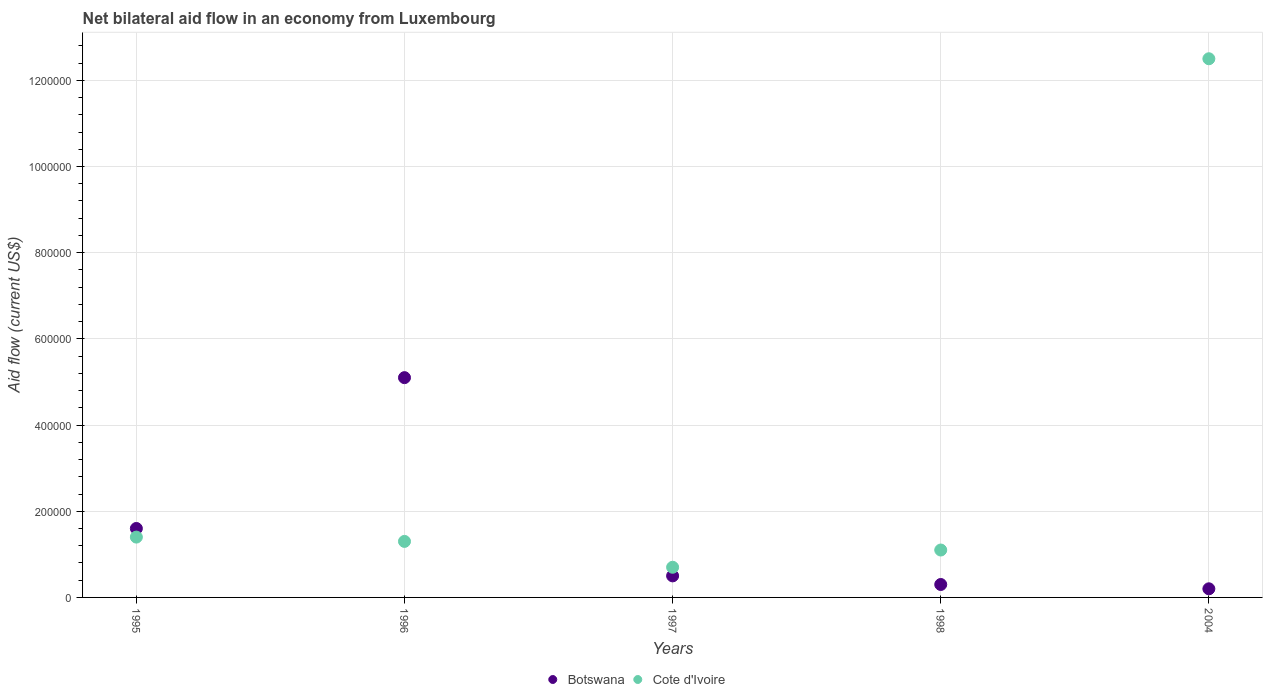How many different coloured dotlines are there?
Make the answer very short. 2. Is the number of dotlines equal to the number of legend labels?
Provide a short and direct response. Yes. What is the net bilateral aid flow in Cote d'Ivoire in 1996?
Keep it short and to the point. 1.30e+05. Across all years, what is the maximum net bilateral aid flow in Botswana?
Your answer should be compact. 5.10e+05. Across all years, what is the minimum net bilateral aid flow in Cote d'Ivoire?
Your answer should be compact. 7.00e+04. In which year was the net bilateral aid flow in Botswana minimum?
Give a very brief answer. 2004. What is the total net bilateral aid flow in Botswana in the graph?
Your response must be concise. 7.70e+05. What is the difference between the net bilateral aid flow in Cote d'Ivoire in 1997 and that in 1998?
Ensure brevity in your answer.  -4.00e+04. What is the difference between the net bilateral aid flow in Cote d'Ivoire in 2004 and the net bilateral aid flow in Botswana in 1995?
Offer a terse response. 1.09e+06. What is the average net bilateral aid flow in Botswana per year?
Your answer should be very brief. 1.54e+05. Is the difference between the net bilateral aid flow in Cote d'Ivoire in 1996 and 1997 greater than the difference between the net bilateral aid flow in Botswana in 1996 and 1997?
Make the answer very short. No. What is the difference between the highest and the second highest net bilateral aid flow in Botswana?
Your response must be concise. 3.50e+05. What is the difference between the highest and the lowest net bilateral aid flow in Botswana?
Your answer should be very brief. 4.90e+05. Is the sum of the net bilateral aid flow in Botswana in 1996 and 1997 greater than the maximum net bilateral aid flow in Cote d'Ivoire across all years?
Offer a very short reply. No. Is the net bilateral aid flow in Cote d'Ivoire strictly less than the net bilateral aid flow in Botswana over the years?
Ensure brevity in your answer.  No. Are the values on the major ticks of Y-axis written in scientific E-notation?
Provide a succinct answer. No. Does the graph contain any zero values?
Your response must be concise. No. What is the title of the graph?
Keep it short and to the point. Net bilateral aid flow in an economy from Luxembourg. Does "Portugal" appear as one of the legend labels in the graph?
Your response must be concise. No. What is the label or title of the X-axis?
Give a very brief answer. Years. What is the label or title of the Y-axis?
Your answer should be compact. Aid flow (current US$). What is the Aid flow (current US$) of Botswana in 1995?
Your response must be concise. 1.60e+05. What is the Aid flow (current US$) in Botswana in 1996?
Offer a terse response. 5.10e+05. What is the Aid flow (current US$) of Cote d'Ivoire in 1996?
Ensure brevity in your answer.  1.30e+05. What is the Aid flow (current US$) of Cote d'Ivoire in 1997?
Ensure brevity in your answer.  7.00e+04. What is the Aid flow (current US$) of Botswana in 1998?
Your answer should be very brief. 3.00e+04. What is the Aid flow (current US$) in Cote d'Ivoire in 1998?
Keep it short and to the point. 1.10e+05. What is the Aid flow (current US$) in Botswana in 2004?
Your answer should be very brief. 2.00e+04. What is the Aid flow (current US$) of Cote d'Ivoire in 2004?
Your answer should be compact. 1.25e+06. Across all years, what is the maximum Aid flow (current US$) of Botswana?
Provide a succinct answer. 5.10e+05. Across all years, what is the maximum Aid flow (current US$) in Cote d'Ivoire?
Provide a short and direct response. 1.25e+06. What is the total Aid flow (current US$) of Botswana in the graph?
Make the answer very short. 7.70e+05. What is the total Aid flow (current US$) in Cote d'Ivoire in the graph?
Provide a succinct answer. 1.70e+06. What is the difference between the Aid flow (current US$) of Botswana in 1995 and that in 1996?
Ensure brevity in your answer.  -3.50e+05. What is the difference between the Aid flow (current US$) in Cote d'Ivoire in 1995 and that in 1996?
Provide a short and direct response. 10000. What is the difference between the Aid flow (current US$) of Botswana in 1995 and that in 2004?
Ensure brevity in your answer.  1.40e+05. What is the difference between the Aid flow (current US$) of Cote d'Ivoire in 1995 and that in 2004?
Provide a short and direct response. -1.11e+06. What is the difference between the Aid flow (current US$) in Botswana in 1996 and that in 1997?
Your answer should be very brief. 4.60e+05. What is the difference between the Aid flow (current US$) in Cote d'Ivoire in 1996 and that in 2004?
Keep it short and to the point. -1.12e+06. What is the difference between the Aid flow (current US$) in Cote d'Ivoire in 1997 and that in 2004?
Make the answer very short. -1.18e+06. What is the difference between the Aid flow (current US$) of Botswana in 1998 and that in 2004?
Provide a short and direct response. 10000. What is the difference between the Aid flow (current US$) of Cote d'Ivoire in 1998 and that in 2004?
Your answer should be very brief. -1.14e+06. What is the difference between the Aid flow (current US$) of Botswana in 1995 and the Aid flow (current US$) of Cote d'Ivoire in 1996?
Offer a very short reply. 3.00e+04. What is the difference between the Aid flow (current US$) in Botswana in 1995 and the Aid flow (current US$) in Cote d'Ivoire in 1997?
Offer a very short reply. 9.00e+04. What is the difference between the Aid flow (current US$) in Botswana in 1995 and the Aid flow (current US$) in Cote d'Ivoire in 2004?
Your answer should be compact. -1.09e+06. What is the difference between the Aid flow (current US$) of Botswana in 1996 and the Aid flow (current US$) of Cote d'Ivoire in 1998?
Offer a very short reply. 4.00e+05. What is the difference between the Aid flow (current US$) of Botswana in 1996 and the Aid flow (current US$) of Cote d'Ivoire in 2004?
Offer a very short reply. -7.40e+05. What is the difference between the Aid flow (current US$) in Botswana in 1997 and the Aid flow (current US$) in Cote d'Ivoire in 1998?
Your response must be concise. -6.00e+04. What is the difference between the Aid flow (current US$) in Botswana in 1997 and the Aid flow (current US$) in Cote d'Ivoire in 2004?
Give a very brief answer. -1.20e+06. What is the difference between the Aid flow (current US$) of Botswana in 1998 and the Aid flow (current US$) of Cote d'Ivoire in 2004?
Offer a terse response. -1.22e+06. What is the average Aid flow (current US$) of Botswana per year?
Your answer should be very brief. 1.54e+05. In the year 1995, what is the difference between the Aid flow (current US$) in Botswana and Aid flow (current US$) in Cote d'Ivoire?
Your response must be concise. 2.00e+04. In the year 2004, what is the difference between the Aid flow (current US$) in Botswana and Aid flow (current US$) in Cote d'Ivoire?
Give a very brief answer. -1.23e+06. What is the ratio of the Aid flow (current US$) of Botswana in 1995 to that in 1996?
Make the answer very short. 0.31. What is the ratio of the Aid flow (current US$) of Botswana in 1995 to that in 1998?
Provide a short and direct response. 5.33. What is the ratio of the Aid flow (current US$) of Cote d'Ivoire in 1995 to that in 1998?
Offer a terse response. 1.27. What is the ratio of the Aid flow (current US$) in Cote d'Ivoire in 1995 to that in 2004?
Give a very brief answer. 0.11. What is the ratio of the Aid flow (current US$) in Botswana in 1996 to that in 1997?
Make the answer very short. 10.2. What is the ratio of the Aid flow (current US$) of Cote d'Ivoire in 1996 to that in 1997?
Offer a terse response. 1.86. What is the ratio of the Aid flow (current US$) in Botswana in 1996 to that in 1998?
Give a very brief answer. 17. What is the ratio of the Aid flow (current US$) of Cote d'Ivoire in 1996 to that in 1998?
Your answer should be very brief. 1.18. What is the ratio of the Aid flow (current US$) in Botswana in 1996 to that in 2004?
Your answer should be compact. 25.5. What is the ratio of the Aid flow (current US$) of Cote d'Ivoire in 1996 to that in 2004?
Make the answer very short. 0.1. What is the ratio of the Aid flow (current US$) in Botswana in 1997 to that in 1998?
Provide a succinct answer. 1.67. What is the ratio of the Aid flow (current US$) in Cote d'Ivoire in 1997 to that in 1998?
Ensure brevity in your answer.  0.64. What is the ratio of the Aid flow (current US$) of Cote d'Ivoire in 1997 to that in 2004?
Provide a short and direct response. 0.06. What is the ratio of the Aid flow (current US$) of Cote d'Ivoire in 1998 to that in 2004?
Ensure brevity in your answer.  0.09. What is the difference between the highest and the second highest Aid flow (current US$) of Cote d'Ivoire?
Offer a terse response. 1.11e+06. What is the difference between the highest and the lowest Aid flow (current US$) of Cote d'Ivoire?
Provide a succinct answer. 1.18e+06. 